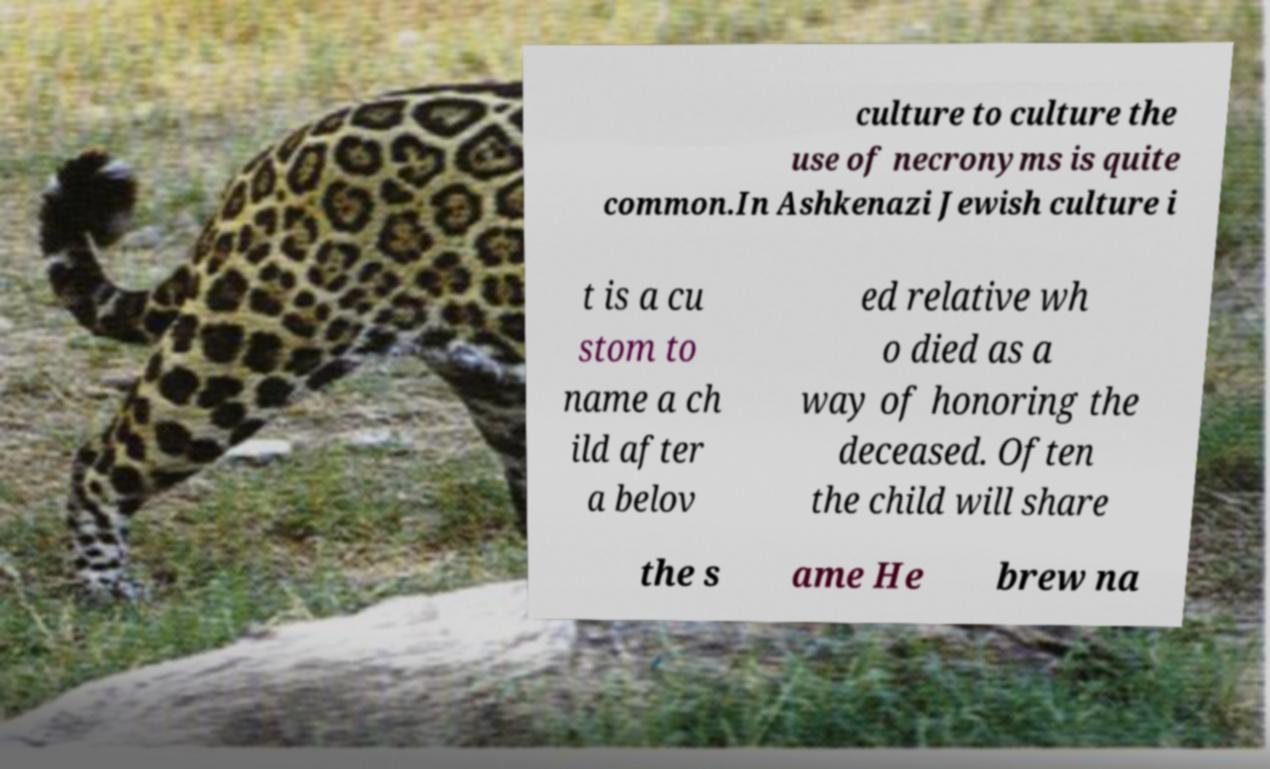Can you accurately transcribe the text from the provided image for me? culture to culture the use of necronyms is quite common.In Ashkenazi Jewish culture i t is a cu stom to name a ch ild after a belov ed relative wh o died as a way of honoring the deceased. Often the child will share the s ame He brew na 